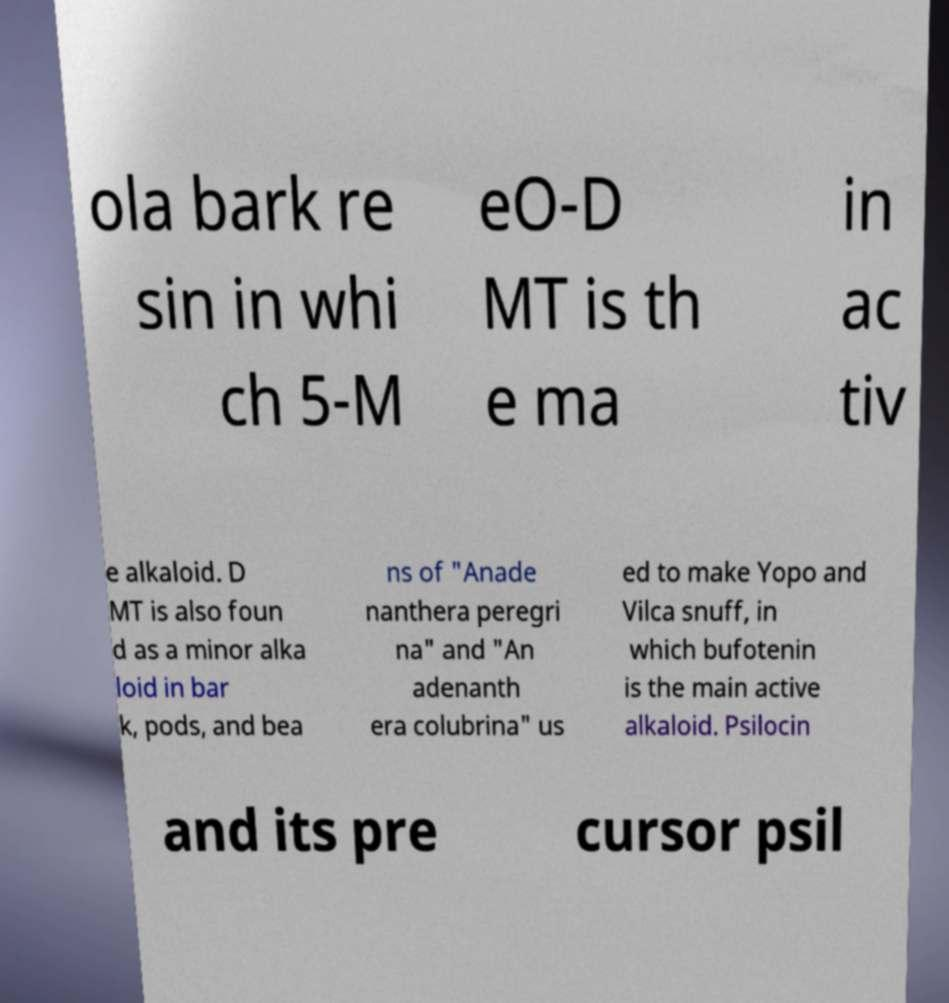Please identify and transcribe the text found in this image. ola bark re sin in whi ch 5-M eO-D MT is th e ma in ac tiv e alkaloid. D MT is also foun d as a minor alka loid in bar k, pods, and bea ns of "Anade nanthera peregri na" and "An adenanth era colubrina" us ed to make Yopo and Vilca snuff, in which bufotenin is the main active alkaloid. Psilocin and its pre cursor psil 